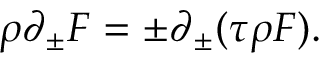Convert formula to latex. <formula><loc_0><loc_0><loc_500><loc_500>\rho \partial _ { \pm } F = \pm \partial _ { \pm } ( \tau \rho F ) .</formula> 